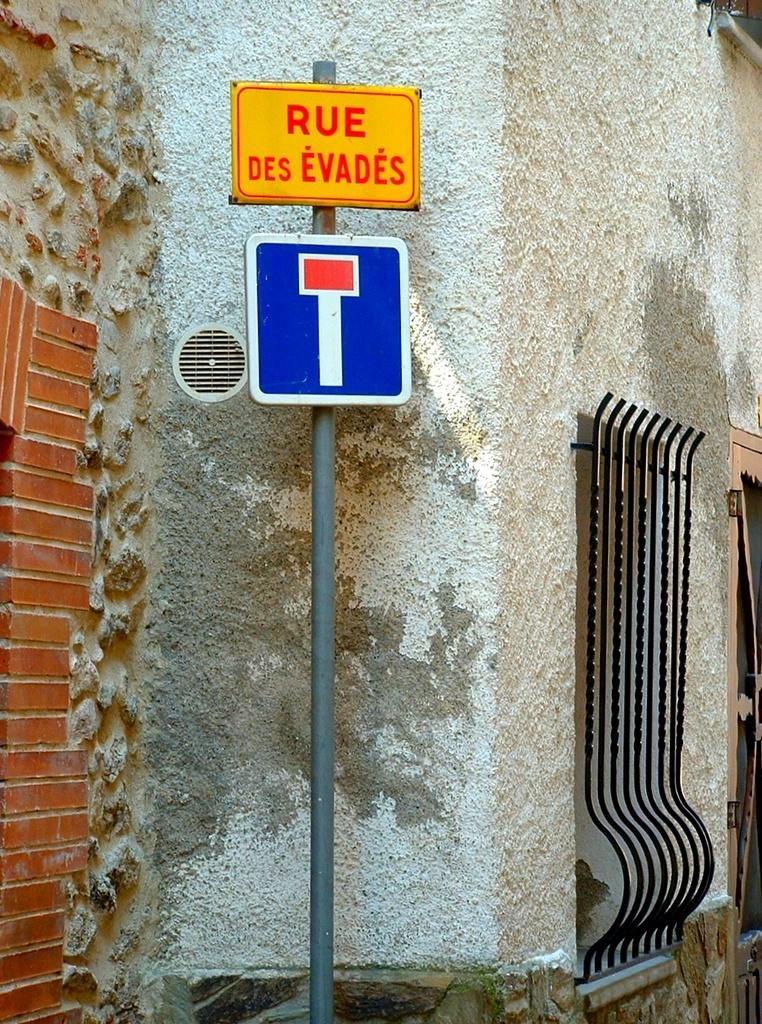<image>
Render a clear and concise summary of the photo. Orange sign which says RUE DES EVADES on top of another sign. 